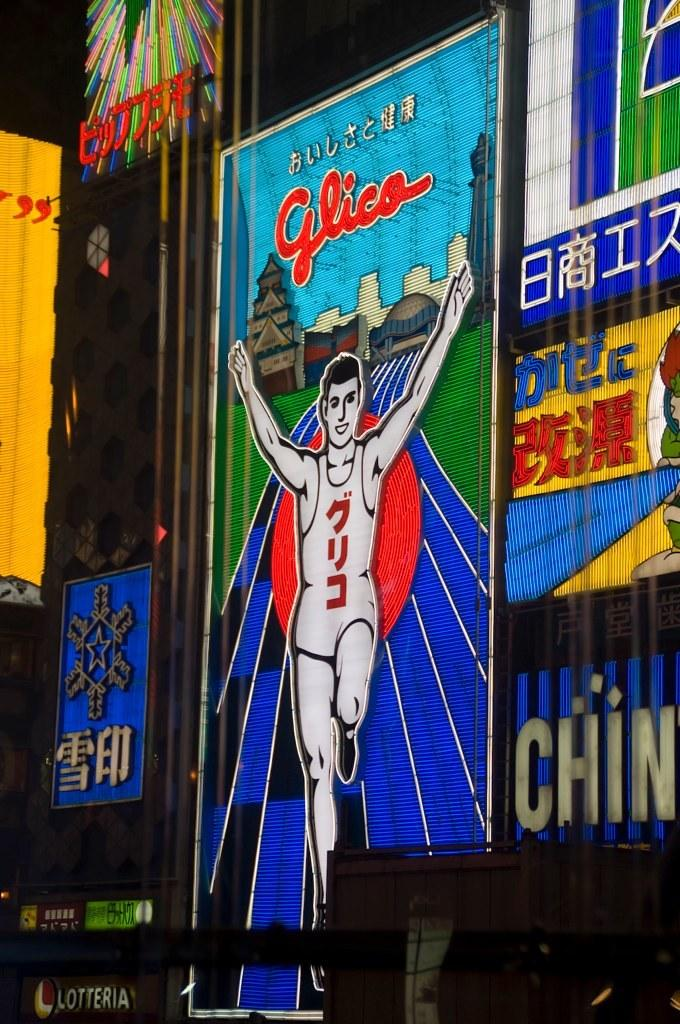Provide a one-sentence caption for the provided image. Various signs on a billboard including an advertisement for Glico. 